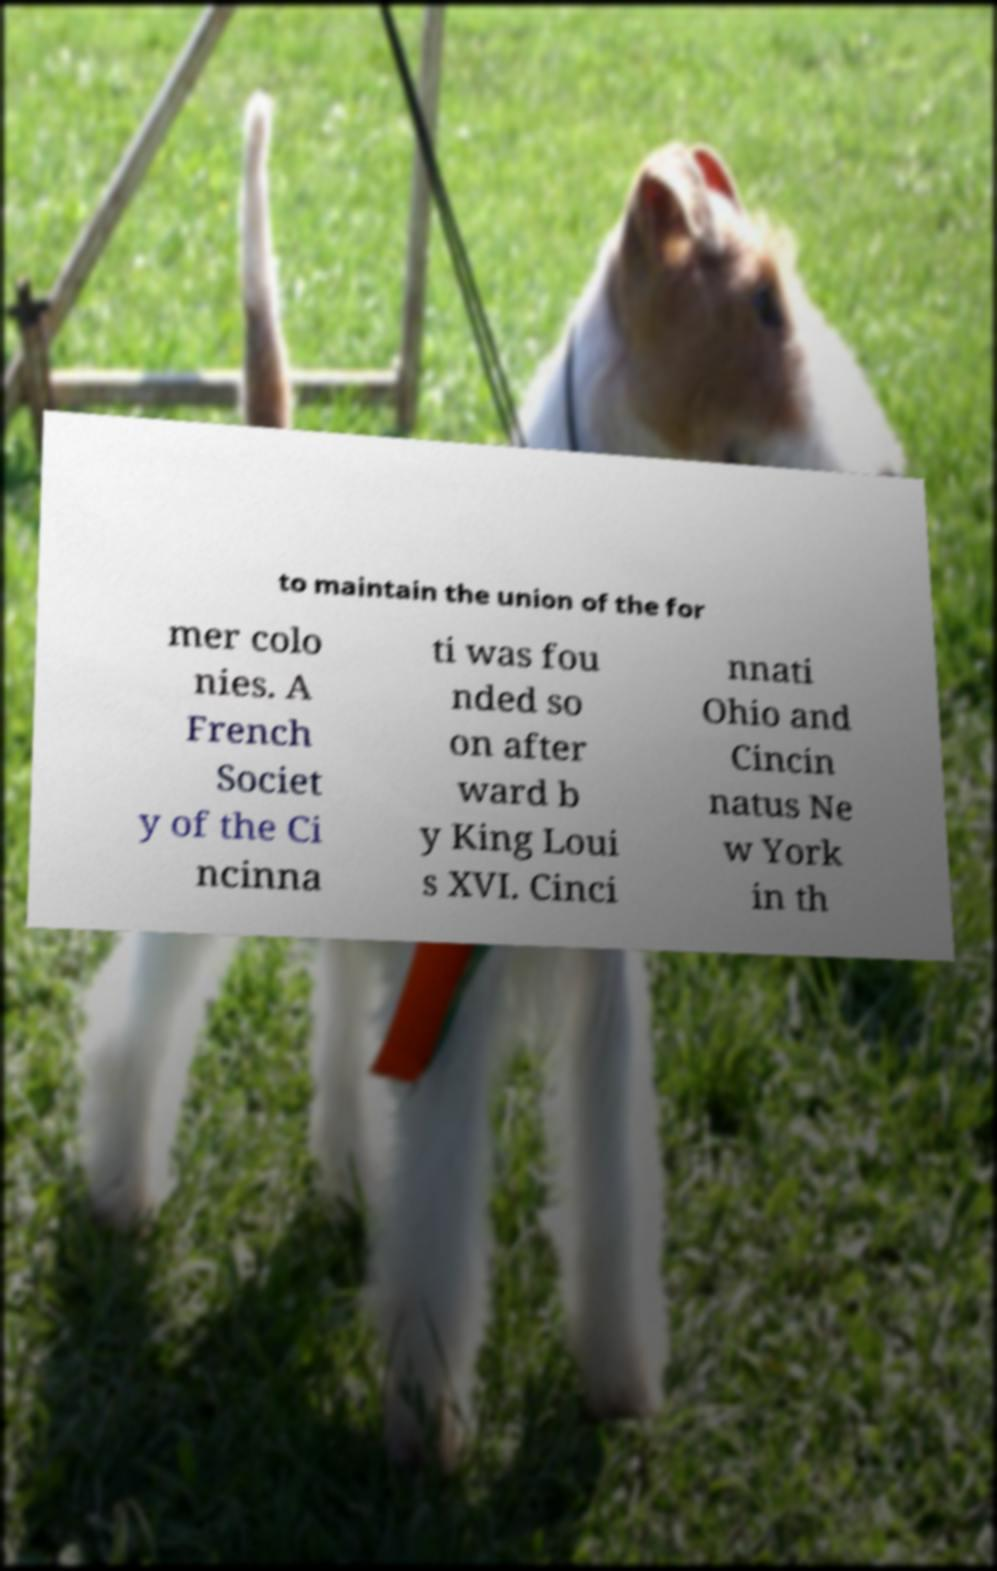Please identify and transcribe the text found in this image. to maintain the union of the for mer colo nies. A French Societ y of the Ci ncinna ti was fou nded so on after ward b y King Loui s XVI. Cinci nnati Ohio and Cincin natus Ne w York in th 